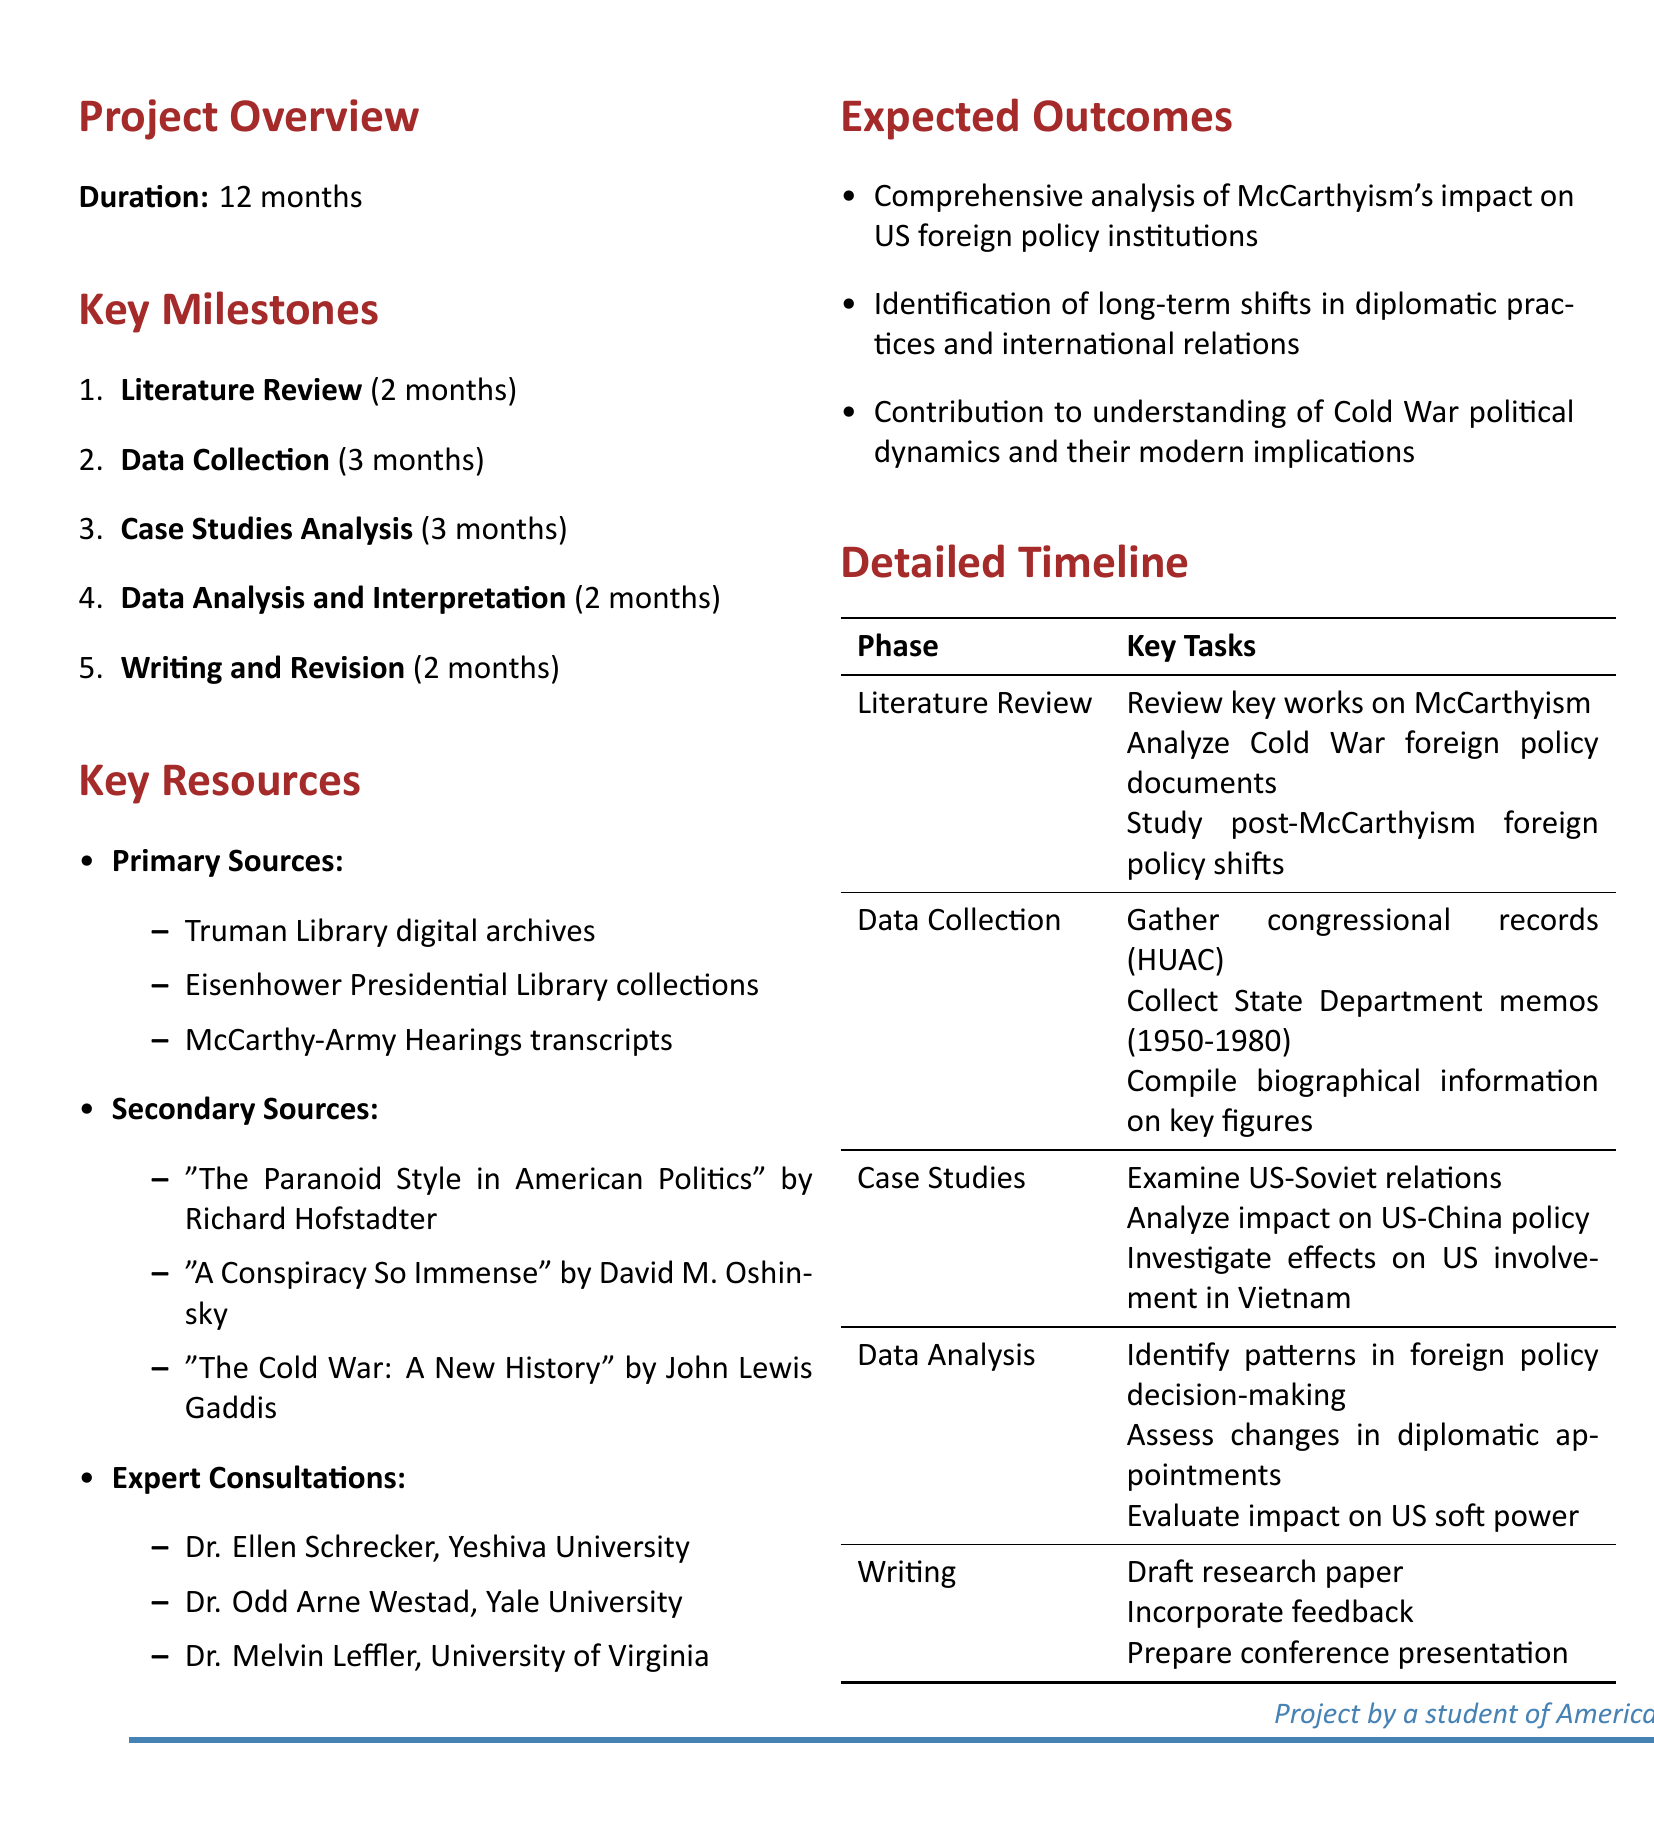What is the project duration? The project duration is specified at the beginning of the document, indicating how long the research project will take.
Answer: 12 months What are the key tasks in the Literature Review phase? The tasks for the Literature Review phase are listed under its corresponding milestone, detailing what will be accomplished during this time.
Answer: Review key works on McCarthyism, Analyze Cold War foreign policy documents, Study post-McCarthyism foreign policy shifts How many months are allocated for Data Collection? The number of months allocated for Data Collection is explicitly mentioned in the milestones section of the document.
Answer: 3 months Who is one of the experts listed for consultations? The document provides a list of experts who can be consulted, highlighting notable scholars in the field.
Answer: Dr. Ellen Schrecker, Yeshiva University What is one expected outcome of the project? The expected outcomes are outlined toward the end of the document, summarizing the contributions of the research project.
Answer: Comprehensive analysis of McCarthyism's impact on US foreign policy institutions What type of sources are included in Primary Sources? The document categorizes the sources into different types and specifies the items in each category, providing clarity on what will be used.
Answer: Truman Library digital archives How many milestones are listed in total? The document enumerates the milestones to be completed within the project, making it easy to determine their total number.
Answer: 5 What analysis will be conducted regarding US-Soviet relations? The specific focus of the case studies section of the project highlights the tasks related to analyzing this aspect of history.
Answer: Examine US-Soviet relations during and after McCarthy era Which software will be used for data analysis? The resources section under Data Analysis and Interpretation clarifies what tools are necessary for this part of the project.
Answer: Statistical analysis software 